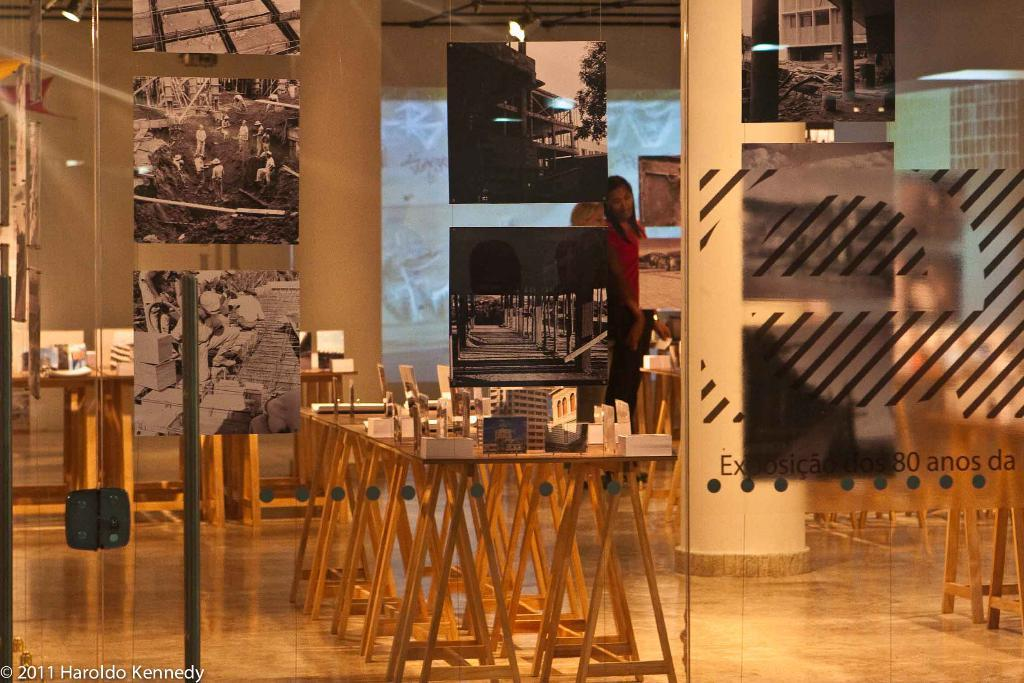What is present on the wall in the image? There is a wall in the image, but no specific details about the wall are mentioned. What can be seen hanging on the wall in the image? There are photo frames in the image. Can you describe the person in the image? There is a person in the image, but no specific details about the person are mentioned. What is the main object in the image that displays visual content? There is a screen in the image. What type of furniture is present in the image? There are tables in the image. What is the process of the person controlling the screen in the image? There is no indication in the image that the person is controlling the screen, nor is there any information about a process. What is the purpose of the photo frames in the image? The purpose of the photo frames in the image is not mentioned in the provided facts. 